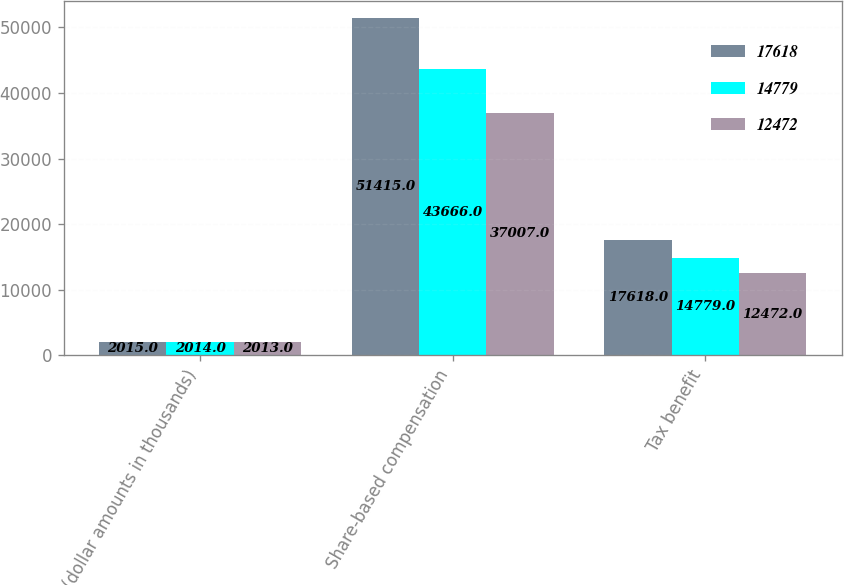Convert chart to OTSL. <chart><loc_0><loc_0><loc_500><loc_500><stacked_bar_chart><ecel><fcel>(dollar amounts in thousands)<fcel>Share-based compensation<fcel>Tax benefit<nl><fcel>17618<fcel>2015<fcel>51415<fcel>17618<nl><fcel>14779<fcel>2014<fcel>43666<fcel>14779<nl><fcel>12472<fcel>2013<fcel>37007<fcel>12472<nl></chart> 